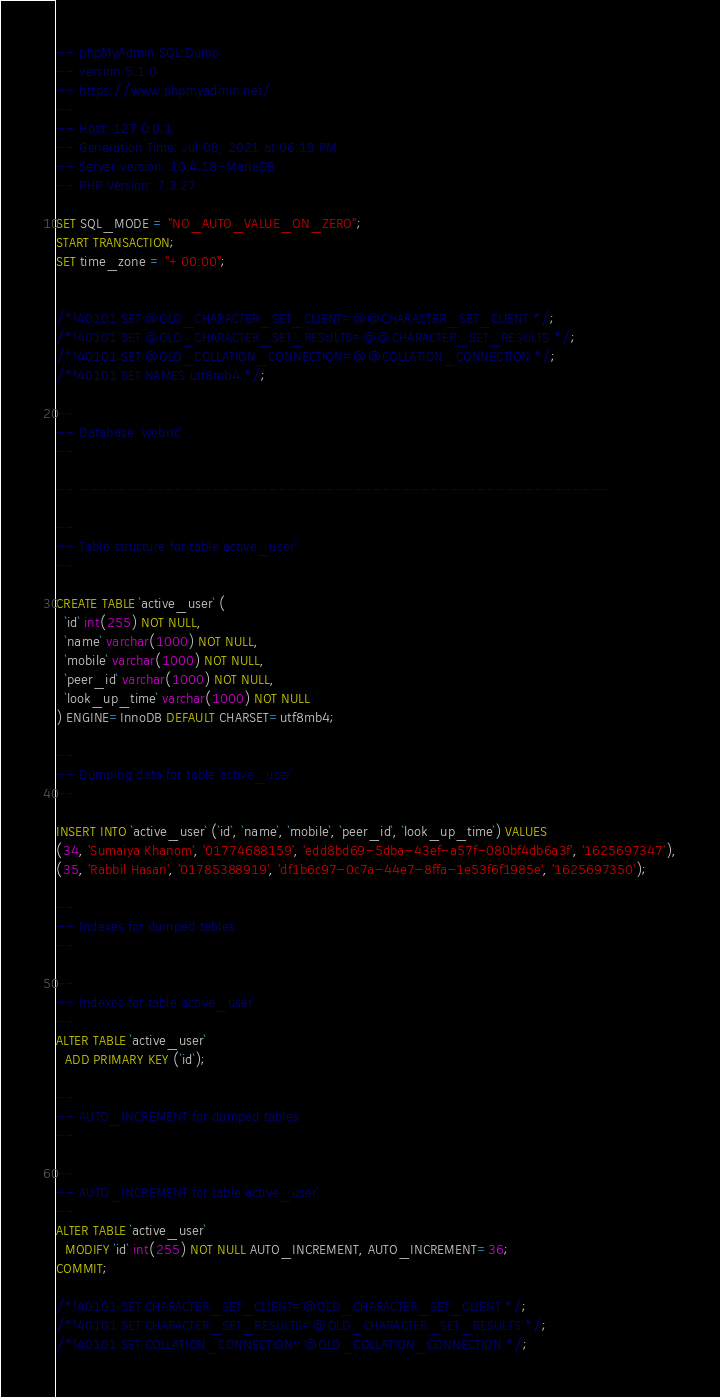<code> <loc_0><loc_0><loc_500><loc_500><_SQL_>-- phpMyAdmin SQL Dump
-- version 5.1.0
-- https://www.phpmyadmin.net/
--
-- Host: 127.0.0.1
-- Generation Time: Jul 08, 2021 at 06:19 PM
-- Server version: 10.4.18-MariaDB
-- PHP Version: 7.3.27

SET SQL_MODE = "NO_AUTO_VALUE_ON_ZERO";
START TRANSACTION;
SET time_zone = "+00:00";


/*!40101 SET @OLD_CHARACTER_SET_CLIENT=@@CHARACTER_SET_CLIENT */;
/*!40101 SET @OLD_CHARACTER_SET_RESULTS=@@CHARACTER_SET_RESULTS */;
/*!40101 SET @OLD_COLLATION_CONNECTION=@@COLLATION_CONNECTION */;
/*!40101 SET NAMES utf8mb4 */;

--
-- Database: `webrtc`
--

-- --------------------------------------------------------

--
-- Table structure for table `active_user`
--

CREATE TABLE `active_user` (
  `id` int(255) NOT NULL,
  `name` varchar(1000) NOT NULL,
  `mobile` varchar(1000) NOT NULL,
  `peer_id` varchar(1000) NOT NULL,
  `look_up_time` varchar(1000) NOT NULL
) ENGINE=InnoDB DEFAULT CHARSET=utf8mb4;

--
-- Dumping data for table `active_user`
--

INSERT INTO `active_user` (`id`, `name`, `mobile`, `peer_id`, `look_up_time`) VALUES
(34, 'Sumaiya Khanom', '01774688159', 'edd8bd69-5dba-43ef-a57f-080bf4db6a3f', '1625697347'),
(35, 'Rabbil Hasan', '01785388919', 'df1b6c97-0c7a-44e7-8ffa-1e53f6f1985e', '1625697350');

--
-- Indexes for dumped tables
--

--
-- Indexes for table `active_user`
--
ALTER TABLE `active_user`
  ADD PRIMARY KEY (`id`);

--
-- AUTO_INCREMENT for dumped tables
--

--
-- AUTO_INCREMENT for table `active_user`
--
ALTER TABLE `active_user`
  MODIFY `id` int(255) NOT NULL AUTO_INCREMENT, AUTO_INCREMENT=36;
COMMIT;

/*!40101 SET CHARACTER_SET_CLIENT=@OLD_CHARACTER_SET_CLIENT */;
/*!40101 SET CHARACTER_SET_RESULTS=@OLD_CHARACTER_SET_RESULTS */;
/*!40101 SET COLLATION_CONNECTION=@OLD_COLLATION_CONNECTION */;
</code> 